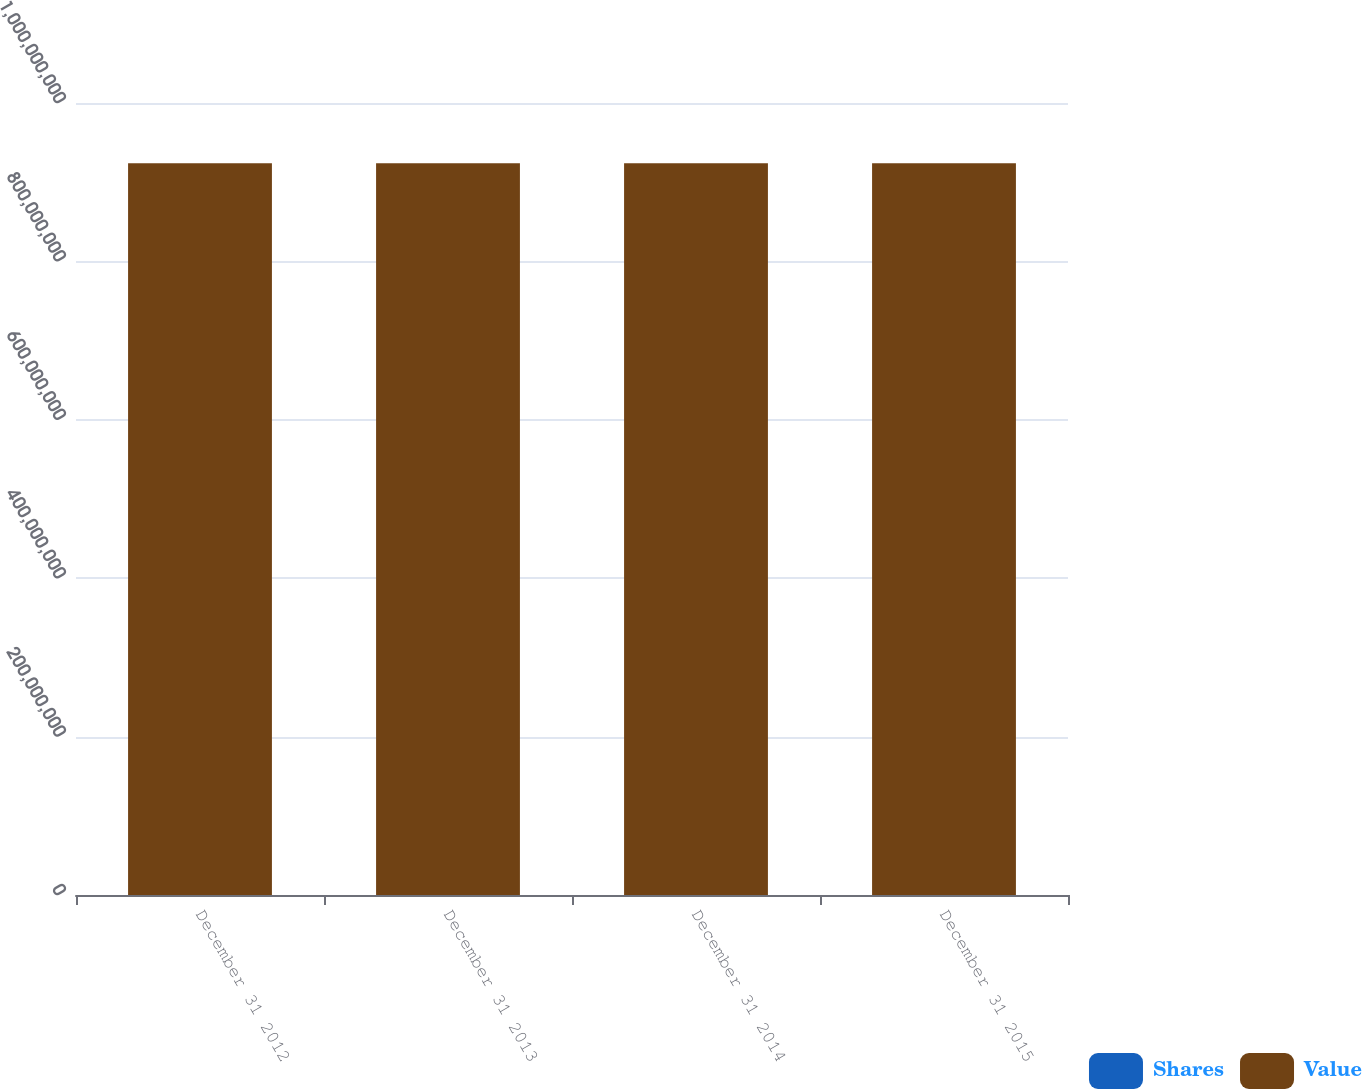<chart> <loc_0><loc_0><loc_500><loc_500><stacked_bar_chart><ecel><fcel>December 31 2012<fcel>December 31 2013<fcel>December 31 2014<fcel>December 31 2015<nl><fcel>Shares<fcel>2051<fcel>2051<fcel>2051<fcel>2051<nl><fcel>Value<fcel>9.23893e+08<fcel>9.23893e+08<fcel>9.23893e+08<fcel>9.23893e+08<nl></chart> 